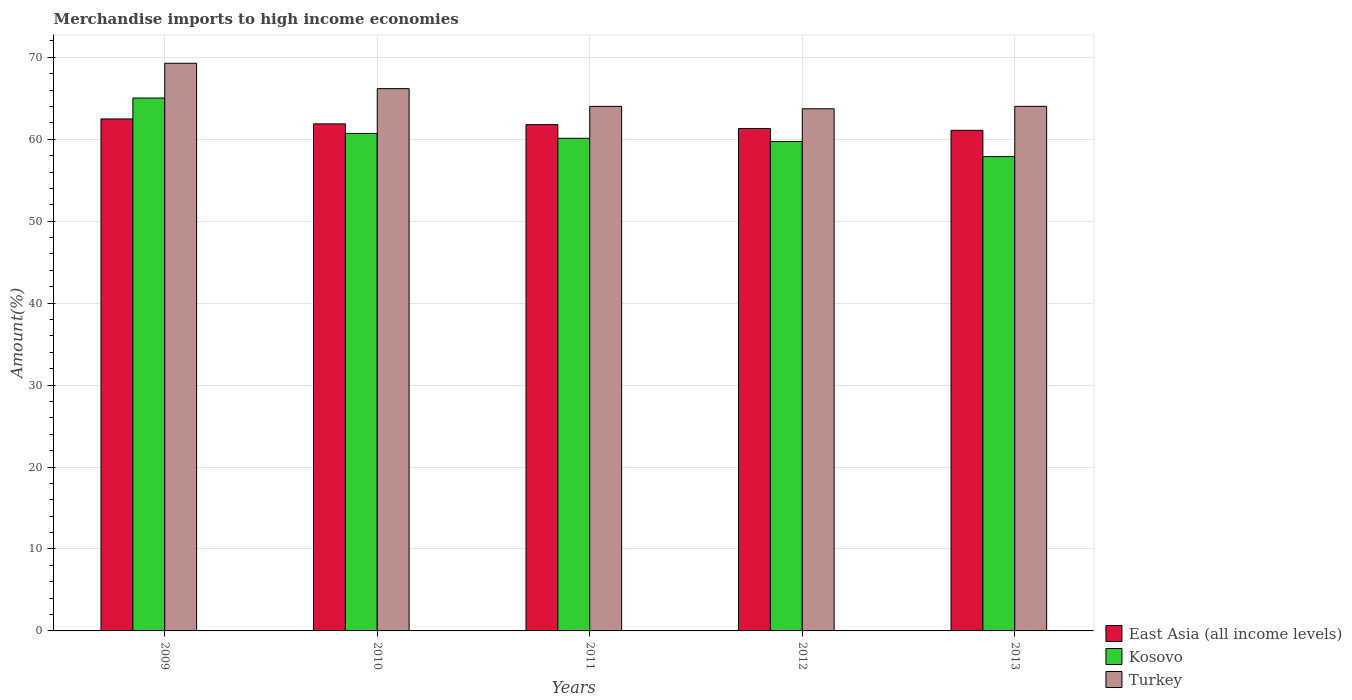How many different coloured bars are there?
Ensure brevity in your answer.  3. How many groups of bars are there?
Your answer should be compact. 5. Are the number of bars per tick equal to the number of legend labels?
Offer a terse response. Yes. What is the label of the 2nd group of bars from the left?
Offer a terse response. 2010. What is the percentage of amount earned from merchandise imports in East Asia (all income levels) in 2011?
Provide a short and direct response. 61.79. Across all years, what is the maximum percentage of amount earned from merchandise imports in Kosovo?
Your answer should be compact. 65.03. Across all years, what is the minimum percentage of amount earned from merchandise imports in East Asia (all income levels)?
Provide a short and direct response. 61.09. In which year was the percentage of amount earned from merchandise imports in East Asia (all income levels) minimum?
Keep it short and to the point. 2013. What is the total percentage of amount earned from merchandise imports in Turkey in the graph?
Provide a short and direct response. 327.21. What is the difference between the percentage of amount earned from merchandise imports in Turkey in 2010 and that in 2011?
Make the answer very short. 2.17. What is the difference between the percentage of amount earned from merchandise imports in Turkey in 2010 and the percentage of amount earned from merchandise imports in East Asia (all income levels) in 2013?
Ensure brevity in your answer.  5.09. What is the average percentage of amount earned from merchandise imports in East Asia (all income levels) per year?
Your answer should be very brief. 61.71. In the year 2010, what is the difference between the percentage of amount earned from merchandise imports in Turkey and percentage of amount earned from merchandise imports in East Asia (all income levels)?
Your response must be concise. 4.3. In how many years, is the percentage of amount earned from merchandise imports in East Asia (all income levels) greater than 36 %?
Ensure brevity in your answer.  5. What is the ratio of the percentage of amount earned from merchandise imports in East Asia (all income levels) in 2010 to that in 2012?
Ensure brevity in your answer.  1.01. What is the difference between the highest and the second highest percentage of amount earned from merchandise imports in East Asia (all income levels)?
Provide a succinct answer. 0.6. What is the difference between the highest and the lowest percentage of amount earned from merchandise imports in Kosovo?
Offer a terse response. 7.15. What does the 1st bar from the left in 2009 represents?
Keep it short and to the point. East Asia (all income levels). What does the 1st bar from the right in 2009 represents?
Ensure brevity in your answer.  Turkey. Are all the bars in the graph horizontal?
Provide a succinct answer. No. How many years are there in the graph?
Offer a very short reply. 5. What is the difference between two consecutive major ticks on the Y-axis?
Provide a succinct answer. 10. Does the graph contain grids?
Your answer should be very brief. Yes. How many legend labels are there?
Make the answer very short. 3. How are the legend labels stacked?
Your answer should be compact. Vertical. What is the title of the graph?
Offer a very short reply. Merchandise imports to high income economies. Does "Lesotho" appear as one of the legend labels in the graph?
Offer a very short reply. No. What is the label or title of the Y-axis?
Your answer should be compact. Amount(%). What is the Amount(%) of East Asia (all income levels) in 2009?
Provide a short and direct response. 62.48. What is the Amount(%) in Kosovo in 2009?
Ensure brevity in your answer.  65.03. What is the Amount(%) in Turkey in 2009?
Provide a short and direct response. 69.28. What is the Amount(%) in East Asia (all income levels) in 2010?
Provide a succinct answer. 61.88. What is the Amount(%) in Kosovo in 2010?
Ensure brevity in your answer.  60.71. What is the Amount(%) in Turkey in 2010?
Make the answer very short. 66.18. What is the Amount(%) in East Asia (all income levels) in 2011?
Ensure brevity in your answer.  61.79. What is the Amount(%) in Kosovo in 2011?
Your answer should be very brief. 60.12. What is the Amount(%) in Turkey in 2011?
Your answer should be very brief. 64.02. What is the Amount(%) in East Asia (all income levels) in 2012?
Make the answer very short. 61.32. What is the Amount(%) of Kosovo in 2012?
Give a very brief answer. 59.72. What is the Amount(%) of Turkey in 2012?
Your response must be concise. 63.72. What is the Amount(%) of East Asia (all income levels) in 2013?
Your response must be concise. 61.09. What is the Amount(%) in Kosovo in 2013?
Offer a very short reply. 57.88. What is the Amount(%) in Turkey in 2013?
Provide a short and direct response. 64.02. Across all years, what is the maximum Amount(%) of East Asia (all income levels)?
Make the answer very short. 62.48. Across all years, what is the maximum Amount(%) in Kosovo?
Your answer should be very brief. 65.03. Across all years, what is the maximum Amount(%) of Turkey?
Your response must be concise. 69.28. Across all years, what is the minimum Amount(%) of East Asia (all income levels)?
Your answer should be compact. 61.09. Across all years, what is the minimum Amount(%) of Kosovo?
Offer a terse response. 57.88. Across all years, what is the minimum Amount(%) in Turkey?
Your answer should be compact. 63.72. What is the total Amount(%) in East Asia (all income levels) in the graph?
Give a very brief answer. 308.55. What is the total Amount(%) of Kosovo in the graph?
Keep it short and to the point. 303.47. What is the total Amount(%) of Turkey in the graph?
Your answer should be very brief. 327.21. What is the difference between the Amount(%) of East Asia (all income levels) in 2009 and that in 2010?
Your answer should be very brief. 0.6. What is the difference between the Amount(%) in Kosovo in 2009 and that in 2010?
Your answer should be very brief. 4.32. What is the difference between the Amount(%) of Turkey in 2009 and that in 2010?
Offer a terse response. 3.1. What is the difference between the Amount(%) in East Asia (all income levels) in 2009 and that in 2011?
Your answer should be very brief. 0.69. What is the difference between the Amount(%) of Kosovo in 2009 and that in 2011?
Keep it short and to the point. 4.91. What is the difference between the Amount(%) in Turkey in 2009 and that in 2011?
Your response must be concise. 5.26. What is the difference between the Amount(%) of East Asia (all income levels) in 2009 and that in 2012?
Provide a short and direct response. 1.16. What is the difference between the Amount(%) of Kosovo in 2009 and that in 2012?
Your response must be concise. 5.31. What is the difference between the Amount(%) in Turkey in 2009 and that in 2012?
Ensure brevity in your answer.  5.55. What is the difference between the Amount(%) of East Asia (all income levels) in 2009 and that in 2013?
Your response must be concise. 1.39. What is the difference between the Amount(%) of Kosovo in 2009 and that in 2013?
Your answer should be very brief. 7.15. What is the difference between the Amount(%) of Turkey in 2009 and that in 2013?
Provide a short and direct response. 5.26. What is the difference between the Amount(%) of East Asia (all income levels) in 2010 and that in 2011?
Give a very brief answer. 0.09. What is the difference between the Amount(%) of Kosovo in 2010 and that in 2011?
Ensure brevity in your answer.  0.59. What is the difference between the Amount(%) in Turkey in 2010 and that in 2011?
Offer a terse response. 2.17. What is the difference between the Amount(%) in East Asia (all income levels) in 2010 and that in 2012?
Keep it short and to the point. 0.56. What is the difference between the Amount(%) of Kosovo in 2010 and that in 2012?
Make the answer very short. 0.99. What is the difference between the Amount(%) of Turkey in 2010 and that in 2012?
Your answer should be very brief. 2.46. What is the difference between the Amount(%) in East Asia (all income levels) in 2010 and that in 2013?
Your response must be concise. 0.79. What is the difference between the Amount(%) of Kosovo in 2010 and that in 2013?
Ensure brevity in your answer.  2.83. What is the difference between the Amount(%) in Turkey in 2010 and that in 2013?
Your answer should be compact. 2.16. What is the difference between the Amount(%) in East Asia (all income levels) in 2011 and that in 2012?
Your answer should be compact. 0.47. What is the difference between the Amount(%) of Kosovo in 2011 and that in 2012?
Your response must be concise. 0.4. What is the difference between the Amount(%) in Turkey in 2011 and that in 2012?
Offer a terse response. 0.29. What is the difference between the Amount(%) of East Asia (all income levels) in 2011 and that in 2013?
Provide a succinct answer. 0.7. What is the difference between the Amount(%) of Kosovo in 2011 and that in 2013?
Ensure brevity in your answer.  2.24. What is the difference between the Amount(%) of Turkey in 2011 and that in 2013?
Offer a terse response. -0. What is the difference between the Amount(%) of East Asia (all income levels) in 2012 and that in 2013?
Offer a terse response. 0.23. What is the difference between the Amount(%) in Kosovo in 2012 and that in 2013?
Offer a very short reply. 1.84. What is the difference between the Amount(%) of Turkey in 2012 and that in 2013?
Your response must be concise. -0.29. What is the difference between the Amount(%) in East Asia (all income levels) in 2009 and the Amount(%) in Kosovo in 2010?
Your answer should be very brief. 1.77. What is the difference between the Amount(%) of East Asia (all income levels) in 2009 and the Amount(%) of Turkey in 2010?
Your answer should be very brief. -3.7. What is the difference between the Amount(%) in Kosovo in 2009 and the Amount(%) in Turkey in 2010?
Give a very brief answer. -1.15. What is the difference between the Amount(%) in East Asia (all income levels) in 2009 and the Amount(%) in Kosovo in 2011?
Offer a very short reply. 2.36. What is the difference between the Amount(%) in East Asia (all income levels) in 2009 and the Amount(%) in Turkey in 2011?
Offer a very short reply. -1.53. What is the difference between the Amount(%) of East Asia (all income levels) in 2009 and the Amount(%) of Kosovo in 2012?
Offer a very short reply. 2.76. What is the difference between the Amount(%) in East Asia (all income levels) in 2009 and the Amount(%) in Turkey in 2012?
Provide a short and direct response. -1.24. What is the difference between the Amount(%) of Kosovo in 2009 and the Amount(%) of Turkey in 2012?
Keep it short and to the point. 1.31. What is the difference between the Amount(%) in East Asia (all income levels) in 2009 and the Amount(%) in Kosovo in 2013?
Make the answer very short. 4.6. What is the difference between the Amount(%) in East Asia (all income levels) in 2009 and the Amount(%) in Turkey in 2013?
Your answer should be very brief. -1.54. What is the difference between the Amount(%) of Kosovo in 2009 and the Amount(%) of Turkey in 2013?
Offer a very short reply. 1.02. What is the difference between the Amount(%) of East Asia (all income levels) in 2010 and the Amount(%) of Kosovo in 2011?
Provide a succinct answer. 1.76. What is the difference between the Amount(%) of East Asia (all income levels) in 2010 and the Amount(%) of Turkey in 2011?
Your answer should be compact. -2.14. What is the difference between the Amount(%) of Kosovo in 2010 and the Amount(%) of Turkey in 2011?
Ensure brevity in your answer.  -3.31. What is the difference between the Amount(%) in East Asia (all income levels) in 2010 and the Amount(%) in Kosovo in 2012?
Offer a very short reply. 2.15. What is the difference between the Amount(%) in East Asia (all income levels) in 2010 and the Amount(%) in Turkey in 2012?
Keep it short and to the point. -1.85. What is the difference between the Amount(%) in Kosovo in 2010 and the Amount(%) in Turkey in 2012?
Provide a succinct answer. -3.01. What is the difference between the Amount(%) in East Asia (all income levels) in 2010 and the Amount(%) in Kosovo in 2013?
Provide a short and direct response. 3.99. What is the difference between the Amount(%) of East Asia (all income levels) in 2010 and the Amount(%) of Turkey in 2013?
Give a very brief answer. -2.14. What is the difference between the Amount(%) in Kosovo in 2010 and the Amount(%) in Turkey in 2013?
Offer a terse response. -3.31. What is the difference between the Amount(%) of East Asia (all income levels) in 2011 and the Amount(%) of Kosovo in 2012?
Ensure brevity in your answer.  2.06. What is the difference between the Amount(%) of East Asia (all income levels) in 2011 and the Amount(%) of Turkey in 2012?
Give a very brief answer. -1.94. What is the difference between the Amount(%) in Kosovo in 2011 and the Amount(%) in Turkey in 2012?
Offer a terse response. -3.6. What is the difference between the Amount(%) of East Asia (all income levels) in 2011 and the Amount(%) of Kosovo in 2013?
Make the answer very short. 3.9. What is the difference between the Amount(%) in East Asia (all income levels) in 2011 and the Amount(%) in Turkey in 2013?
Ensure brevity in your answer.  -2.23. What is the difference between the Amount(%) in Kosovo in 2011 and the Amount(%) in Turkey in 2013?
Make the answer very short. -3.9. What is the difference between the Amount(%) in East Asia (all income levels) in 2012 and the Amount(%) in Kosovo in 2013?
Provide a succinct answer. 3.43. What is the difference between the Amount(%) of East Asia (all income levels) in 2012 and the Amount(%) of Turkey in 2013?
Provide a succinct answer. -2.7. What is the difference between the Amount(%) of Kosovo in 2012 and the Amount(%) of Turkey in 2013?
Ensure brevity in your answer.  -4.29. What is the average Amount(%) of East Asia (all income levels) per year?
Your answer should be very brief. 61.71. What is the average Amount(%) in Kosovo per year?
Provide a short and direct response. 60.69. What is the average Amount(%) in Turkey per year?
Provide a short and direct response. 65.44. In the year 2009, what is the difference between the Amount(%) in East Asia (all income levels) and Amount(%) in Kosovo?
Make the answer very short. -2.55. In the year 2009, what is the difference between the Amount(%) of East Asia (all income levels) and Amount(%) of Turkey?
Offer a terse response. -6.8. In the year 2009, what is the difference between the Amount(%) of Kosovo and Amount(%) of Turkey?
Ensure brevity in your answer.  -4.24. In the year 2010, what is the difference between the Amount(%) in East Asia (all income levels) and Amount(%) in Kosovo?
Offer a very short reply. 1.17. In the year 2010, what is the difference between the Amount(%) in East Asia (all income levels) and Amount(%) in Turkey?
Keep it short and to the point. -4.3. In the year 2010, what is the difference between the Amount(%) in Kosovo and Amount(%) in Turkey?
Give a very brief answer. -5.47. In the year 2011, what is the difference between the Amount(%) in East Asia (all income levels) and Amount(%) in Kosovo?
Offer a very short reply. 1.67. In the year 2011, what is the difference between the Amount(%) of East Asia (all income levels) and Amount(%) of Turkey?
Provide a short and direct response. -2.23. In the year 2011, what is the difference between the Amount(%) of Kosovo and Amount(%) of Turkey?
Ensure brevity in your answer.  -3.9. In the year 2012, what is the difference between the Amount(%) in East Asia (all income levels) and Amount(%) in Kosovo?
Keep it short and to the point. 1.59. In the year 2012, what is the difference between the Amount(%) in East Asia (all income levels) and Amount(%) in Turkey?
Offer a very short reply. -2.41. In the year 2012, what is the difference between the Amount(%) of Kosovo and Amount(%) of Turkey?
Provide a succinct answer. -4. In the year 2013, what is the difference between the Amount(%) in East Asia (all income levels) and Amount(%) in Kosovo?
Offer a very short reply. 3.21. In the year 2013, what is the difference between the Amount(%) of East Asia (all income levels) and Amount(%) of Turkey?
Offer a very short reply. -2.93. In the year 2013, what is the difference between the Amount(%) in Kosovo and Amount(%) in Turkey?
Make the answer very short. -6.13. What is the ratio of the Amount(%) in East Asia (all income levels) in 2009 to that in 2010?
Offer a terse response. 1.01. What is the ratio of the Amount(%) of Kosovo in 2009 to that in 2010?
Offer a terse response. 1.07. What is the ratio of the Amount(%) in Turkey in 2009 to that in 2010?
Give a very brief answer. 1.05. What is the ratio of the Amount(%) of East Asia (all income levels) in 2009 to that in 2011?
Offer a terse response. 1.01. What is the ratio of the Amount(%) in Kosovo in 2009 to that in 2011?
Your answer should be compact. 1.08. What is the ratio of the Amount(%) in Turkey in 2009 to that in 2011?
Your answer should be very brief. 1.08. What is the ratio of the Amount(%) in East Asia (all income levels) in 2009 to that in 2012?
Give a very brief answer. 1.02. What is the ratio of the Amount(%) in Kosovo in 2009 to that in 2012?
Make the answer very short. 1.09. What is the ratio of the Amount(%) of Turkey in 2009 to that in 2012?
Provide a succinct answer. 1.09. What is the ratio of the Amount(%) of East Asia (all income levels) in 2009 to that in 2013?
Provide a succinct answer. 1.02. What is the ratio of the Amount(%) in Kosovo in 2009 to that in 2013?
Your answer should be compact. 1.12. What is the ratio of the Amount(%) in Turkey in 2009 to that in 2013?
Ensure brevity in your answer.  1.08. What is the ratio of the Amount(%) in East Asia (all income levels) in 2010 to that in 2011?
Offer a very short reply. 1. What is the ratio of the Amount(%) in Kosovo in 2010 to that in 2011?
Your answer should be compact. 1.01. What is the ratio of the Amount(%) of Turkey in 2010 to that in 2011?
Provide a succinct answer. 1.03. What is the ratio of the Amount(%) of East Asia (all income levels) in 2010 to that in 2012?
Your answer should be very brief. 1.01. What is the ratio of the Amount(%) in Kosovo in 2010 to that in 2012?
Keep it short and to the point. 1.02. What is the ratio of the Amount(%) in Turkey in 2010 to that in 2012?
Keep it short and to the point. 1.04. What is the ratio of the Amount(%) of East Asia (all income levels) in 2010 to that in 2013?
Keep it short and to the point. 1.01. What is the ratio of the Amount(%) of Kosovo in 2010 to that in 2013?
Your answer should be compact. 1.05. What is the ratio of the Amount(%) of Turkey in 2010 to that in 2013?
Make the answer very short. 1.03. What is the ratio of the Amount(%) in East Asia (all income levels) in 2011 to that in 2012?
Give a very brief answer. 1.01. What is the ratio of the Amount(%) in Kosovo in 2011 to that in 2012?
Your answer should be very brief. 1.01. What is the ratio of the Amount(%) of East Asia (all income levels) in 2011 to that in 2013?
Ensure brevity in your answer.  1.01. What is the ratio of the Amount(%) in Kosovo in 2011 to that in 2013?
Make the answer very short. 1.04. What is the ratio of the Amount(%) of East Asia (all income levels) in 2012 to that in 2013?
Ensure brevity in your answer.  1. What is the ratio of the Amount(%) of Kosovo in 2012 to that in 2013?
Your answer should be very brief. 1.03. What is the ratio of the Amount(%) of Turkey in 2012 to that in 2013?
Give a very brief answer. 1. What is the difference between the highest and the second highest Amount(%) in East Asia (all income levels)?
Your answer should be very brief. 0.6. What is the difference between the highest and the second highest Amount(%) of Kosovo?
Provide a succinct answer. 4.32. What is the difference between the highest and the second highest Amount(%) of Turkey?
Your answer should be compact. 3.1. What is the difference between the highest and the lowest Amount(%) of East Asia (all income levels)?
Ensure brevity in your answer.  1.39. What is the difference between the highest and the lowest Amount(%) in Kosovo?
Your answer should be compact. 7.15. What is the difference between the highest and the lowest Amount(%) of Turkey?
Your answer should be compact. 5.55. 